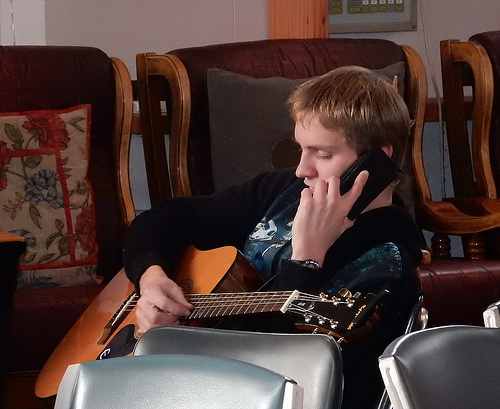<image>
Is there a man in front of the guitar? No. The man is not in front of the guitar. The spatial positioning shows a different relationship between these objects. 